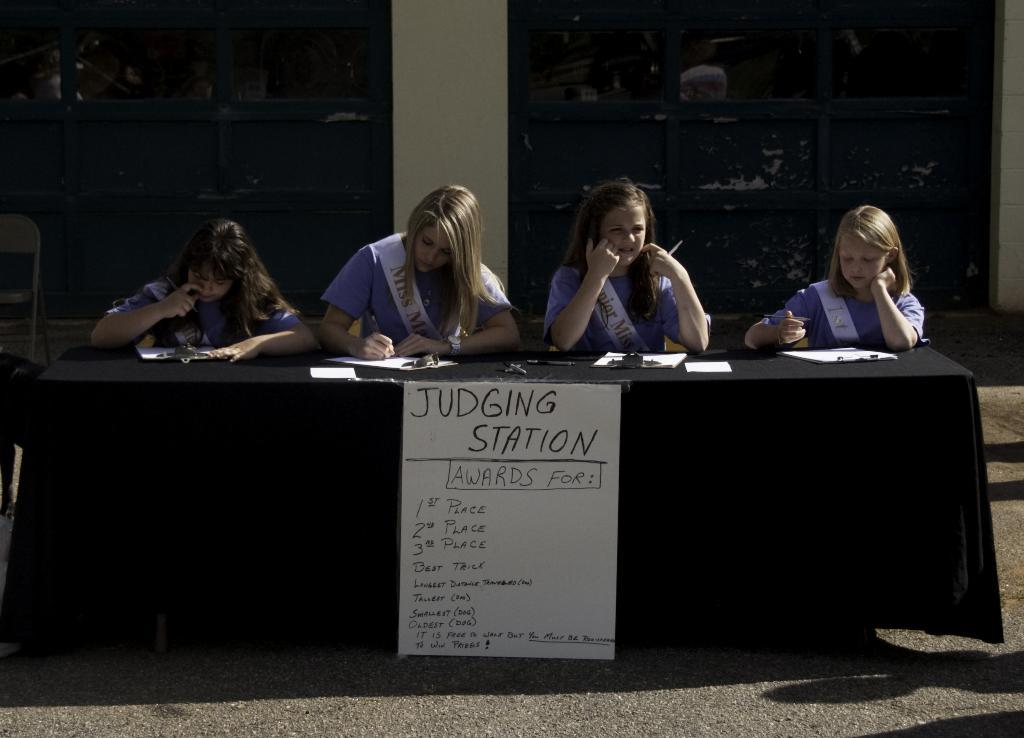How many people are in the image? There are four persons in the image. What are the persons doing in the image? The persons are sitting on chairs and writing on paper. What is the setting of the image? There is a table, a poster, a road, and a pillar in the image. What type of spark can be seen coming from the laborer's tool in the image? There is no laborer or tool present in the image, so there is no spark to be seen. 